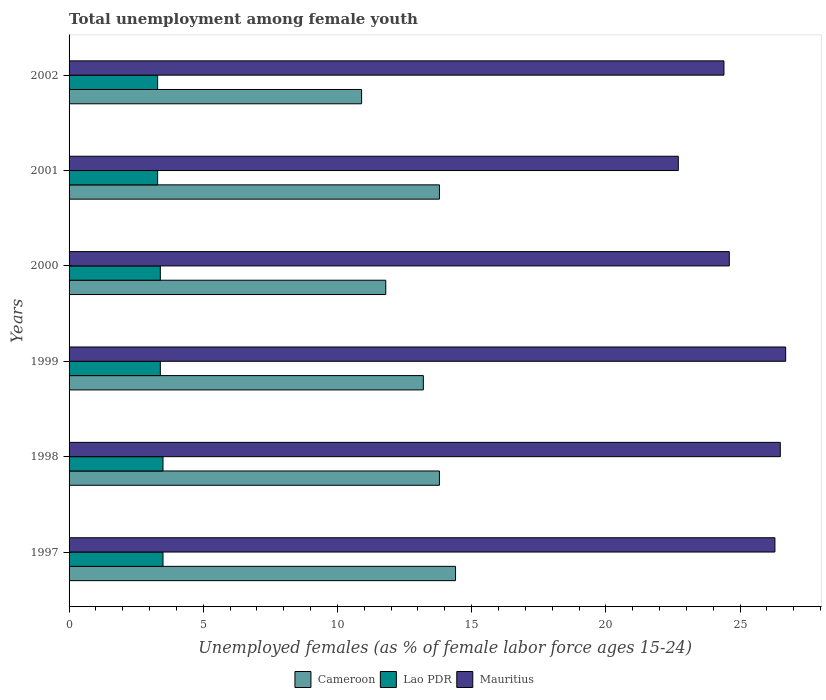How many different coloured bars are there?
Offer a terse response. 3. Are the number of bars per tick equal to the number of legend labels?
Offer a very short reply. Yes. Are the number of bars on each tick of the Y-axis equal?
Ensure brevity in your answer.  Yes. In how many cases, is the number of bars for a given year not equal to the number of legend labels?
Make the answer very short. 0. What is the percentage of unemployed females in in Mauritius in 1998?
Provide a succinct answer. 26.5. Across all years, what is the maximum percentage of unemployed females in in Cameroon?
Provide a succinct answer. 14.4. Across all years, what is the minimum percentage of unemployed females in in Mauritius?
Give a very brief answer. 22.7. What is the total percentage of unemployed females in in Lao PDR in the graph?
Your response must be concise. 20.4. What is the difference between the percentage of unemployed females in in Cameroon in 1997 and that in 1998?
Offer a very short reply. 0.6. What is the difference between the percentage of unemployed females in in Lao PDR in 1997 and the percentage of unemployed females in in Cameroon in 1999?
Offer a very short reply. -9.7. What is the average percentage of unemployed females in in Mauritius per year?
Provide a short and direct response. 25.2. In the year 1998, what is the difference between the percentage of unemployed females in in Lao PDR and percentage of unemployed females in in Cameroon?
Give a very brief answer. -10.3. What is the ratio of the percentage of unemployed females in in Mauritius in 1997 to that in 2002?
Your answer should be compact. 1.08. Is the difference between the percentage of unemployed females in in Lao PDR in 1999 and 2001 greater than the difference between the percentage of unemployed females in in Cameroon in 1999 and 2001?
Offer a very short reply. Yes. What is the difference between the highest and the second highest percentage of unemployed females in in Mauritius?
Ensure brevity in your answer.  0.2. What does the 3rd bar from the top in 2001 represents?
Provide a succinct answer. Cameroon. What does the 1st bar from the bottom in 1997 represents?
Your answer should be compact. Cameroon. Is it the case that in every year, the sum of the percentage of unemployed females in in Cameroon and percentage of unemployed females in in Lao PDR is greater than the percentage of unemployed females in in Mauritius?
Your answer should be compact. No. How many bars are there?
Ensure brevity in your answer.  18. Are all the bars in the graph horizontal?
Provide a succinct answer. Yes. How many years are there in the graph?
Your response must be concise. 6. What is the difference between two consecutive major ticks on the X-axis?
Provide a succinct answer. 5. Are the values on the major ticks of X-axis written in scientific E-notation?
Your answer should be very brief. No. Does the graph contain any zero values?
Your answer should be very brief. No. Does the graph contain grids?
Offer a very short reply. No. How many legend labels are there?
Your response must be concise. 3. How are the legend labels stacked?
Offer a very short reply. Horizontal. What is the title of the graph?
Give a very brief answer. Total unemployment among female youth. What is the label or title of the X-axis?
Your answer should be compact. Unemployed females (as % of female labor force ages 15-24). What is the label or title of the Y-axis?
Your response must be concise. Years. What is the Unemployed females (as % of female labor force ages 15-24) of Cameroon in 1997?
Your response must be concise. 14.4. What is the Unemployed females (as % of female labor force ages 15-24) in Lao PDR in 1997?
Your answer should be compact. 3.5. What is the Unemployed females (as % of female labor force ages 15-24) in Mauritius in 1997?
Your answer should be very brief. 26.3. What is the Unemployed females (as % of female labor force ages 15-24) in Cameroon in 1998?
Offer a terse response. 13.8. What is the Unemployed females (as % of female labor force ages 15-24) of Cameroon in 1999?
Provide a succinct answer. 13.2. What is the Unemployed females (as % of female labor force ages 15-24) in Lao PDR in 1999?
Your response must be concise. 3.4. What is the Unemployed females (as % of female labor force ages 15-24) in Mauritius in 1999?
Ensure brevity in your answer.  26.7. What is the Unemployed females (as % of female labor force ages 15-24) in Cameroon in 2000?
Make the answer very short. 11.8. What is the Unemployed females (as % of female labor force ages 15-24) of Lao PDR in 2000?
Offer a terse response. 3.4. What is the Unemployed females (as % of female labor force ages 15-24) of Mauritius in 2000?
Keep it short and to the point. 24.6. What is the Unemployed females (as % of female labor force ages 15-24) in Cameroon in 2001?
Offer a terse response. 13.8. What is the Unemployed females (as % of female labor force ages 15-24) in Lao PDR in 2001?
Your answer should be compact. 3.3. What is the Unemployed females (as % of female labor force ages 15-24) of Mauritius in 2001?
Offer a very short reply. 22.7. What is the Unemployed females (as % of female labor force ages 15-24) in Cameroon in 2002?
Keep it short and to the point. 10.9. What is the Unemployed females (as % of female labor force ages 15-24) in Lao PDR in 2002?
Give a very brief answer. 3.3. What is the Unemployed females (as % of female labor force ages 15-24) of Mauritius in 2002?
Your answer should be very brief. 24.4. Across all years, what is the maximum Unemployed females (as % of female labor force ages 15-24) in Cameroon?
Provide a succinct answer. 14.4. Across all years, what is the maximum Unemployed females (as % of female labor force ages 15-24) of Lao PDR?
Your response must be concise. 3.5. Across all years, what is the maximum Unemployed females (as % of female labor force ages 15-24) of Mauritius?
Make the answer very short. 26.7. Across all years, what is the minimum Unemployed females (as % of female labor force ages 15-24) of Cameroon?
Offer a very short reply. 10.9. Across all years, what is the minimum Unemployed females (as % of female labor force ages 15-24) of Lao PDR?
Give a very brief answer. 3.3. Across all years, what is the minimum Unemployed females (as % of female labor force ages 15-24) in Mauritius?
Keep it short and to the point. 22.7. What is the total Unemployed females (as % of female labor force ages 15-24) of Cameroon in the graph?
Your answer should be very brief. 77.9. What is the total Unemployed females (as % of female labor force ages 15-24) in Lao PDR in the graph?
Your answer should be compact. 20.4. What is the total Unemployed females (as % of female labor force ages 15-24) of Mauritius in the graph?
Provide a succinct answer. 151.2. What is the difference between the Unemployed females (as % of female labor force ages 15-24) of Mauritius in 1997 and that in 1998?
Your answer should be compact. -0.2. What is the difference between the Unemployed females (as % of female labor force ages 15-24) in Cameroon in 1997 and that in 1999?
Your response must be concise. 1.2. What is the difference between the Unemployed females (as % of female labor force ages 15-24) of Cameroon in 1997 and that in 2000?
Make the answer very short. 2.6. What is the difference between the Unemployed females (as % of female labor force ages 15-24) in Mauritius in 1997 and that in 2000?
Offer a very short reply. 1.7. What is the difference between the Unemployed females (as % of female labor force ages 15-24) in Cameroon in 1997 and that in 2001?
Ensure brevity in your answer.  0.6. What is the difference between the Unemployed females (as % of female labor force ages 15-24) of Lao PDR in 1997 and that in 2001?
Your response must be concise. 0.2. What is the difference between the Unemployed females (as % of female labor force ages 15-24) in Cameroon in 1997 and that in 2002?
Give a very brief answer. 3.5. What is the difference between the Unemployed females (as % of female labor force ages 15-24) of Lao PDR in 1997 and that in 2002?
Your answer should be compact. 0.2. What is the difference between the Unemployed females (as % of female labor force ages 15-24) of Mauritius in 1997 and that in 2002?
Give a very brief answer. 1.9. What is the difference between the Unemployed females (as % of female labor force ages 15-24) in Cameroon in 1998 and that in 1999?
Give a very brief answer. 0.6. What is the difference between the Unemployed females (as % of female labor force ages 15-24) in Mauritius in 1998 and that in 1999?
Provide a succinct answer. -0.2. What is the difference between the Unemployed females (as % of female labor force ages 15-24) in Lao PDR in 1998 and that in 2000?
Ensure brevity in your answer.  0.1. What is the difference between the Unemployed females (as % of female labor force ages 15-24) in Mauritius in 1998 and that in 2000?
Give a very brief answer. 1.9. What is the difference between the Unemployed females (as % of female labor force ages 15-24) of Cameroon in 1998 and that in 2001?
Offer a very short reply. 0. What is the difference between the Unemployed females (as % of female labor force ages 15-24) in Lao PDR in 1998 and that in 2001?
Provide a succinct answer. 0.2. What is the difference between the Unemployed females (as % of female labor force ages 15-24) of Mauritius in 1998 and that in 2001?
Keep it short and to the point. 3.8. What is the difference between the Unemployed females (as % of female labor force ages 15-24) of Mauritius in 1998 and that in 2002?
Your answer should be compact. 2.1. What is the difference between the Unemployed females (as % of female labor force ages 15-24) in Cameroon in 1999 and that in 2000?
Provide a short and direct response. 1.4. What is the difference between the Unemployed females (as % of female labor force ages 15-24) in Lao PDR in 1999 and that in 2000?
Keep it short and to the point. 0. What is the difference between the Unemployed females (as % of female labor force ages 15-24) in Mauritius in 1999 and that in 2001?
Offer a very short reply. 4. What is the difference between the Unemployed females (as % of female labor force ages 15-24) of Cameroon in 1999 and that in 2002?
Your response must be concise. 2.3. What is the difference between the Unemployed females (as % of female labor force ages 15-24) of Lao PDR in 2000 and that in 2001?
Give a very brief answer. 0.1. What is the difference between the Unemployed females (as % of female labor force ages 15-24) of Cameroon in 2000 and that in 2002?
Your answer should be compact. 0.9. What is the difference between the Unemployed females (as % of female labor force ages 15-24) of Lao PDR in 2000 and that in 2002?
Provide a succinct answer. 0.1. What is the difference between the Unemployed females (as % of female labor force ages 15-24) in Cameroon in 2001 and that in 2002?
Your answer should be compact. 2.9. What is the difference between the Unemployed females (as % of female labor force ages 15-24) of Mauritius in 2001 and that in 2002?
Provide a short and direct response. -1.7. What is the difference between the Unemployed females (as % of female labor force ages 15-24) in Cameroon in 1997 and the Unemployed females (as % of female labor force ages 15-24) in Mauritius in 1998?
Your response must be concise. -12.1. What is the difference between the Unemployed females (as % of female labor force ages 15-24) of Cameroon in 1997 and the Unemployed females (as % of female labor force ages 15-24) of Lao PDR in 1999?
Offer a very short reply. 11. What is the difference between the Unemployed females (as % of female labor force ages 15-24) of Lao PDR in 1997 and the Unemployed females (as % of female labor force ages 15-24) of Mauritius in 1999?
Provide a short and direct response. -23.2. What is the difference between the Unemployed females (as % of female labor force ages 15-24) in Cameroon in 1997 and the Unemployed females (as % of female labor force ages 15-24) in Mauritius in 2000?
Keep it short and to the point. -10.2. What is the difference between the Unemployed females (as % of female labor force ages 15-24) of Lao PDR in 1997 and the Unemployed females (as % of female labor force ages 15-24) of Mauritius in 2000?
Your answer should be compact. -21.1. What is the difference between the Unemployed females (as % of female labor force ages 15-24) of Cameroon in 1997 and the Unemployed females (as % of female labor force ages 15-24) of Lao PDR in 2001?
Offer a terse response. 11.1. What is the difference between the Unemployed females (as % of female labor force ages 15-24) in Cameroon in 1997 and the Unemployed females (as % of female labor force ages 15-24) in Mauritius in 2001?
Provide a short and direct response. -8.3. What is the difference between the Unemployed females (as % of female labor force ages 15-24) of Lao PDR in 1997 and the Unemployed females (as % of female labor force ages 15-24) of Mauritius in 2001?
Give a very brief answer. -19.2. What is the difference between the Unemployed females (as % of female labor force ages 15-24) of Cameroon in 1997 and the Unemployed females (as % of female labor force ages 15-24) of Lao PDR in 2002?
Offer a terse response. 11.1. What is the difference between the Unemployed females (as % of female labor force ages 15-24) of Cameroon in 1997 and the Unemployed females (as % of female labor force ages 15-24) of Mauritius in 2002?
Ensure brevity in your answer.  -10. What is the difference between the Unemployed females (as % of female labor force ages 15-24) of Lao PDR in 1997 and the Unemployed females (as % of female labor force ages 15-24) of Mauritius in 2002?
Give a very brief answer. -20.9. What is the difference between the Unemployed females (as % of female labor force ages 15-24) in Cameroon in 1998 and the Unemployed females (as % of female labor force ages 15-24) in Lao PDR in 1999?
Ensure brevity in your answer.  10.4. What is the difference between the Unemployed females (as % of female labor force ages 15-24) in Cameroon in 1998 and the Unemployed females (as % of female labor force ages 15-24) in Mauritius in 1999?
Offer a terse response. -12.9. What is the difference between the Unemployed females (as % of female labor force ages 15-24) in Lao PDR in 1998 and the Unemployed females (as % of female labor force ages 15-24) in Mauritius in 1999?
Make the answer very short. -23.2. What is the difference between the Unemployed females (as % of female labor force ages 15-24) in Cameroon in 1998 and the Unemployed females (as % of female labor force ages 15-24) in Lao PDR in 2000?
Offer a terse response. 10.4. What is the difference between the Unemployed females (as % of female labor force ages 15-24) in Lao PDR in 1998 and the Unemployed females (as % of female labor force ages 15-24) in Mauritius in 2000?
Give a very brief answer. -21.1. What is the difference between the Unemployed females (as % of female labor force ages 15-24) in Lao PDR in 1998 and the Unemployed females (as % of female labor force ages 15-24) in Mauritius in 2001?
Offer a terse response. -19.2. What is the difference between the Unemployed females (as % of female labor force ages 15-24) of Cameroon in 1998 and the Unemployed females (as % of female labor force ages 15-24) of Lao PDR in 2002?
Give a very brief answer. 10.5. What is the difference between the Unemployed females (as % of female labor force ages 15-24) in Cameroon in 1998 and the Unemployed females (as % of female labor force ages 15-24) in Mauritius in 2002?
Your answer should be very brief. -10.6. What is the difference between the Unemployed females (as % of female labor force ages 15-24) in Lao PDR in 1998 and the Unemployed females (as % of female labor force ages 15-24) in Mauritius in 2002?
Make the answer very short. -20.9. What is the difference between the Unemployed females (as % of female labor force ages 15-24) in Cameroon in 1999 and the Unemployed females (as % of female labor force ages 15-24) in Mauritius in 2000?
Keep it short and to the point. -11.4. What is the difference between the Unemployed females (as % of female labor force ages 15-24) of Lao PDR in 1999 and the Unemployed females (as % of female labor force ages 15-24) of Mauritius in 2000?
Your response must be concise. -21.2. What is the difference between the Unemployed females (as % of female labor force ages 15-24) in Cameroon in 1999 and the Unemployed females (as % of female labor force ages 15-24) in Lao PDR in 2001?
Make the answer very short. 9.9. What is the difference between the Unemployed females (as % of female labor force ages 15-24) in Lao PDR in 1999 and the Unemployed females (as % of female labor force ages 15-24) in Mauritius in 2001?
Your response must be concise. -19.3. What is the difference between the Unemployed females (as % of female labor force ages 15-24) of Cameroon in 1999 and the Unemployed females (as % of female labor force ages 15-24) of Mauritius in 2002?
Ensure brevity in your answer.  -11.2. What is the difference between the Unemployed females (as % of female labor force ages 15-24) of Cameroon in 2000 and the Unemployed females (as % of female labor force ages 15-24) of Mauritius in 2001?
Give a very brief answer. -10.9. What is the difference between the Unemployed females (as % of female labor force ages 15-24) in Lao PDR in 2000 and the Unemployed females (as % of female labor force ages 15-24) in Mauritius in 2001?
Your response must be concise. -19.3. What is the difference between the Unemployed females (as % of female labor force ages 15-24) of Cameroon in 2000 and the Unemployed females (as % of female labor force ages 15-24) of Lao PDR in 2002?
Keep it short and to the point. 8.5. What is the difference between the Unemployed females (as % of female labor force ages 15-24) in Lao PDR in 2000 and the Unemployed females (as % of female labor force ages 15-24) in Mauritius in 2002?
Offer a terse response. -21. What is the difference between the Unemployed females (as % of female labor force ages 15-24) in Cameroon in 2001 and the Unemployed females (as % of female labor force ages 15-24) in Mauritius in 2002?
Provide a succinct answer. -10.6. What is the difference between the Unemployed females (as % of female labor force ages 15-24) in Lao PDR in 2001 and the Unemployed females (as % of female labor force ages 15-24) in Mauritius in 2002?
Make the answer very short. -21.1. What is the average Unemployed females (as % of female labor force ages 15-24) of Cameroon per year?
Offer a terse response. 12.98. What is the average Unemployed females (as % of female labor force ages 15-24) of Mauritius per year?
Your answer should be very brief. 25.2. In the year 1997, what is the difference between the Unemployed females (as % of female labor force ages 15-24) of Cameroon and Unemployed females (as % of female labor force ages 15-24) of Mauritius?
Provide a short and direct response. -11.9. In the year 1997, what is the difference between the Unemployed females (as % of female labor force ages 15-24) in Lao PDR and Unemployed females (as % of female labor force ages 15-24) in Mauritius?
Make the answer very short. -22.8. In the year 1998, what is the difference between the Unemployed females (as % of female labor force ages 15-24) of Cameroon and Unemployed females (as % of female labor force ages 15-24) of Lao PDR?
Make the answer very short. 10.3. In the year 1998, what is the difference between the Unemployed females (as % of female labor force ages 15-24) of Cameroon and Unemployed females (as % of female labor force ages 15-24) of Mauritius?
Provide a short and direct response. -12.7. In the year 1999, what is the difference between the Unemployed females (as % of female labor force ages 15-24) in Lao PDR and Unemployed females (as % of female labor force ages 15-24) in Mauritius?
Provide a short and direct response. -23.3. In the year 2000, what is the difference between the Unemployed females (as % of female labor force ages 15-24) in Cameroon and Unemployed females (as % of female labor force ages 15-24) in Lao PDR?
Your response must be concise. 8.4. In the year 2000, what is the difference between the Unemployed females (as % of female labor force ages 15-24) in Lao PDR and Unemployed females (as % of female labor force ages 15-24) in Mauritius?
Provide a short and direct response. -21.2. In the year 2001, what is the difference between the Unemployed females (as % of female labor force ages 15-24) of Lao PDR and Unemployed females (as % of female labor force ages 15-24) of Mauritius?
Provide a succinct answer. -19.4. In the year 2002, what is the difference between the Unemployed females (as % of female labor force ages 15-24) of Lao PDR and Unemployed females (as % of female labor force ages 15-24) of Mauritius?
Make the answer very short. -21.1. What is the ratio of the Unemployed females (as % of female labor force ages 15-24) of Cameroon in 1997 to that in 1998?
Your answer should be compact. 1.04. What is the ratio of the Unemployed females (as % of female labor force ages 15-24) in Lao PDR in 1997 to that in 1998?
Provide a succinct answer. 1. What is the ratio of the Unemployed females (as % of female labor force ages 15-24) in Cameroon in 1997 to that in 1999?
Provide a short and direct response. 1.09. What is the ratio of the Unemployed females (as % of female labor force ages 15-24) in Lao PDR in 1997 to that in 1999?
Keep it short and to the point. 1.03. What is the ratio of the Unemployed females (as % of female labor force ages 15-24) in Cameroon in 1997 to that in 2000?
Give a very brief answer. 1.22. What is the ratio of the Unemployed females (as % of female labor force ages 15-24) in Lao PDR in 1997 to that in 2000?
Your answer should be very brief. 1.03. What is the ratio of the Unemployed females (as % of female labor force ages 15-24) in Mauritius in 1997 to that in 2000?
Give a very brief answer. 1.07. What is the ratio of the Unemployed females (as % of female labor force ages 15-24) of Cameroon in 1997 to that in 2001?
Your response must be concise. 1.04. What is the ratio of the Unemployed females (as % of female labor force ages 15-24) of Lao PDR in 1997 to that in 2001?
Your answer should be very brief. 1.06. What is the ratio of the Unemployed females (as % of female labor force ages 15-24) of Mauritius in 1997 to that in 2001?
Your answer should be very brief. 1.16. What is the ratio of the Unemployed females (as % of female labor force ages 15-24) in Cameroon in 1997 to that in 2002?
Keep it short and to the point. 1.32. What is the ratio of the Unemployed females (as % of female labor force ages 15-24) of Lao PDR in 1997 to that in 2002?
Offer a terse response. 1.06. What is the ratio of the Unemployed females (as % of female labor force ages 15-24) of Mauritius in 1997 to that in 2002?
Offer a very short reply. 1.08. What is the ratio of the Unemployed females (as % of female labor force ages 15-24) of Cameroon in 1998 to that in 1999?
Your answer should be very brief. 1.05. What is the ratio of the Unemployed females (as % of female labor force ages 15-24) of Lao PDR in 1998 to that in 1999?
Offer a very short reply. 1.03. What is the ratio of the Unemployed females (as % of female labor force ages 15-24) in Cameroon in 1998 to that in 2000?
Give a very brief answer. 1.17. What is the ratio of the Unemployed females (as % of female labor force ages 15-24) in Lao PDR in 1998 to that in 2000?
Your answer should be compact. 1.03. What is the ratio of the Unemployed females (as % of female labor force ages 15-24) of Mauritius in 1998 to that in 2000?
Your answer should be very brief. 1.08. What is the ratio of the Unemployed females (as % of female labor force ages 15-24) of Cameroon in 1998 to that in 2001?
Provide a succinct answer. 1. What is the ratio of the Unemployed females (as % of female labor force ages 15-24) of Lao PDR in 1998 to that in 2001?
Your answer should be compact. 1.06. What is the ratio of the Unemployed females (as % of female labor force ages 15-24) of Mauritius in 1998 to that in 2001?
Provide a succinct answer. 1.17. What is the ratio of the Unemployed females (as % of female labor force ages 15-24) of Cameroon in 1998 to that in 2002?
Give a very brief answer. 1.27. What is the ratio of the Unemployed females (as % of female labor force ages 15-24) of Lao PDR in 1998 to that in 2002?
Make the answer very short. 1.06. What is the ratio of the Unemployed females (as % of female labor force ages 15-24) of Mauritius in 1998 to that in 2002?
Provide a succinct answer. 1.09. What is the ratio of the Unemployed females (as % of female labor force ages 15-24) in Cameroon in 1999 to that in 2000?
Offer a terse response. 1.12. What is the ratio of the Unemployed females (as % of female labor force ages 15-24) in Mauritius in 1999 to that in 2000?
Provide a short and direct response. 1.09. What is the ratio of the Unemployed females (as % of female labor force ages 15-24) in Cameroon in 1999 to that in 2001?
Make the answer very short. 0.96. What is the ratio of the Unemployed females (as % of female labor force ages 15-24) in Lao PDR in 1999 to that in 2001?
Provide a succinct answer. 1.03. What is the ratio of the Unemployed females (as % of female labor force ages 15-24) of Mauritius in 1999 to that in 2001?
Offer a very short reply. 1.18. What is the ratio of the Unemployed females (as % of female labor force ages 15-24) in Cameroon in 1999 to that in 2002?
Ensure brevity in your answer.  1.21. What is the ratio of the Unemployed females (as % of female labor force ages 15-24) of Lao PDR in 1999 to that in 2002?
Make the answer very short. 1.03. What is the ratio of the Unemployed females (as % of female labor force ages 15-24) in Mauritius in 1999 to that in 2002?
Your answer should be compact. 1.09. What is the ratio of the Unemployed females (as % of female labor force ages 15-24) of Cameroon in 2000 to that in 2001?
Give a very brief answer. 0.86. What is the ratio of the Unemployed females (as % of female labor force ages 15-24) of Lao PDR in 2000 to that in 2001?
Give a very brief answer. 1.03. What is the ratio of the Unemployed females (as % of female labor force ages 15-24) of Mauritius in 2000 to that in 2001?
Your answer should be compact. 1.08. What is the ratio of the Unemployed females (as % of female labor force ages 15-24) of Cameroon in 2000 to that in 2002?
Your answer should be compact. 1.08. What is the ratio of the Unemployed females (as % of female labor force ages 15-24) of Lao PDR in 2000 to that in 2002?
Ensure brevity in your answer.  1.03. What is the ratio of the Unemployed females (as % of female labor force ages 15-24) of Mauritius in 2000 to that in 2002?
Your response must be concise. 1.01. What is the ratio of the Unemployed females (as % of female labor force ages 15-24) in Cameroon in 2001 to that in 2002?
Make the answer very short. 1.27. What is the ratio of the Unemployed females (as % of female labor force ages 15-24) of Mauritius in 2001 to that in 2002?
Your answer should be compact. 0.93. What is the difference between the highest and the lowest Unemployed females (as % of female labor force ages 15-24) of Cameroon?
Your answer should be compact. 3.5. What is the difference between the highest and the lowest Unemployed females (as % of female labor force ages 15-24) of Lao PDR?
Offer a very short reply. 0.2. 